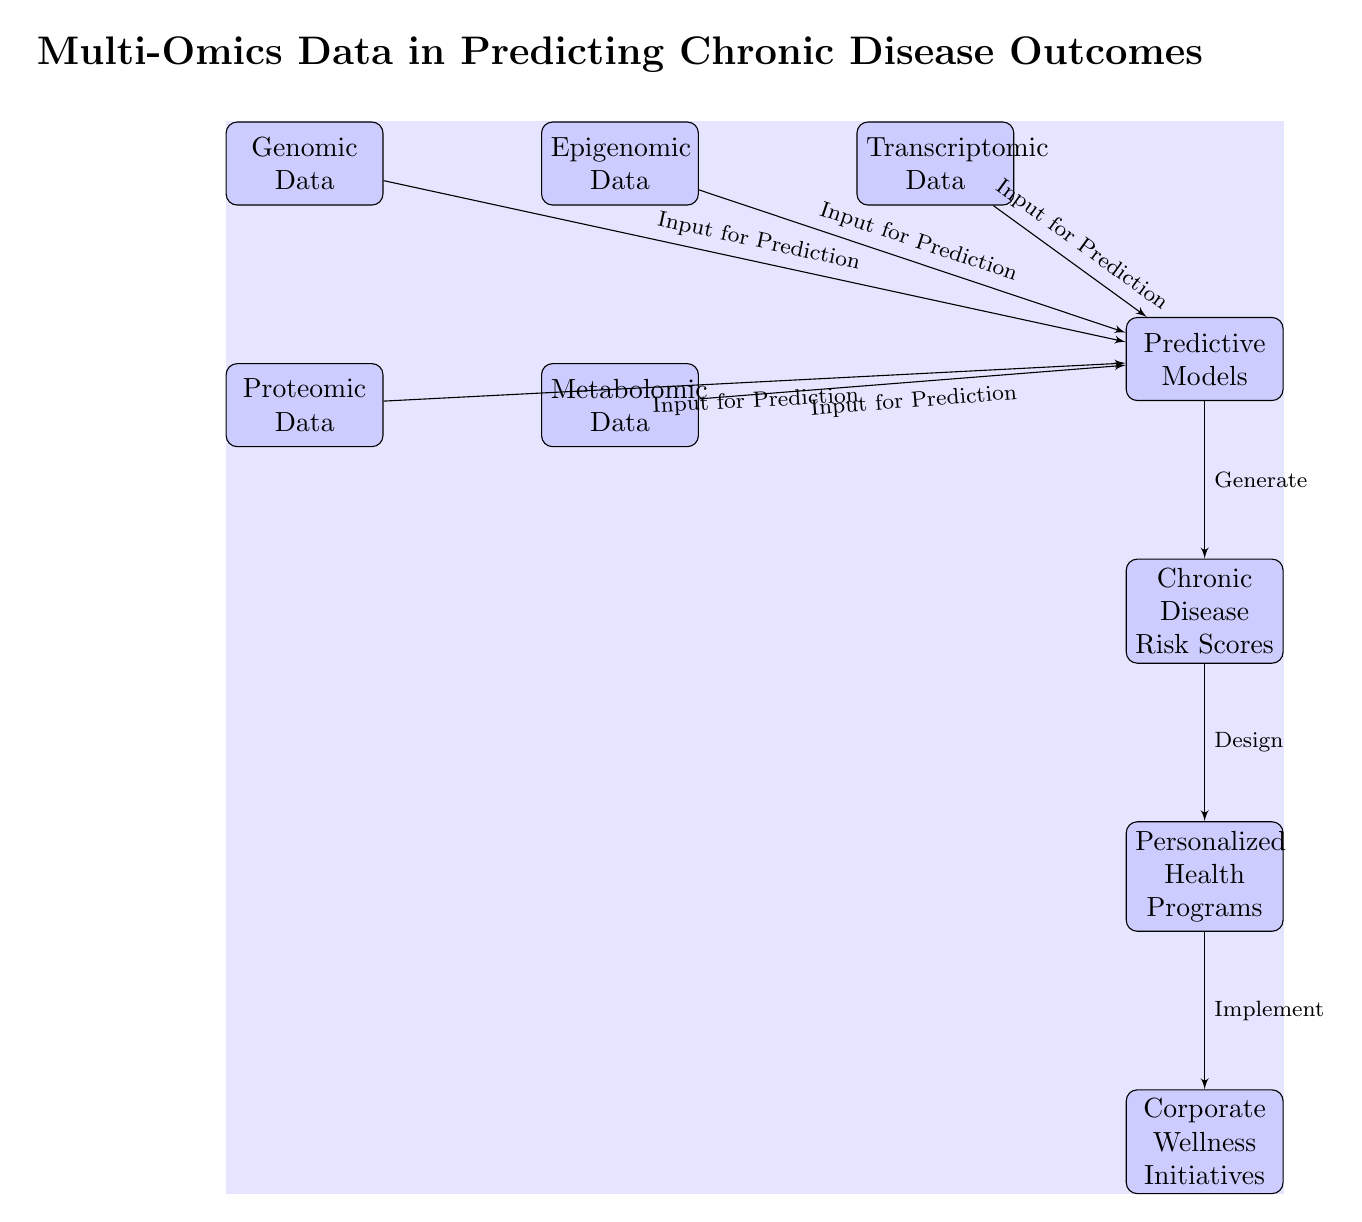What are the five types of omics data represented in this diagram? The diagram shows five types of omics data including Genomic Data, Epigenomic Data, Transcriptomic Data, Proteomic Data, and Metabolomic Data, which are each labeled within their respective blocks.
Answer: Genomic Data, Epigenomic Data, Transcriptomic Data, Proteomic Data, Metabolomic Data Who generates the Chronic Disease Risk Scores? The Predictive Models node generates the Chronic Disease Risk Scores as indicated by the directed edge leading from the Predictive Models to the Chronic Disease Risk Scores.
Answer: Predictive Models How many blocks are in the diagram? By counting the distinct blocks (Genomic Data, Epigenomic Data, Transcriptomic Data, Proteomic Data, Metabolomic Data, Predictive Models, Chronic Disease Risk Scores, Personalized Health Programs, Corporate Wellness Initiatives), there are a total of nine blocks in the diagram.
Answer: Nine What is the relationship between Personalized Health Programs and Corporate Wellness Initiatives? The diagram shows that Personalized Health Programs are designed to lead to Corporate Wellness Initiatives, as represented by the directed edge from Personalized Health Programs to Corporate Wellness Initiatives labeled "Implement."
Answer: Design Which node serves as input from all five omics data types? The Predictive Models node receives inputs from the five omics data types (Genomic Data, Epigenomic Data, Transcriptomic Data, Proteomic Data, Metabolomic Data) as shown by the edges connecting each of these blocks to the Predictive Models block.
Answer: Predictive Models 